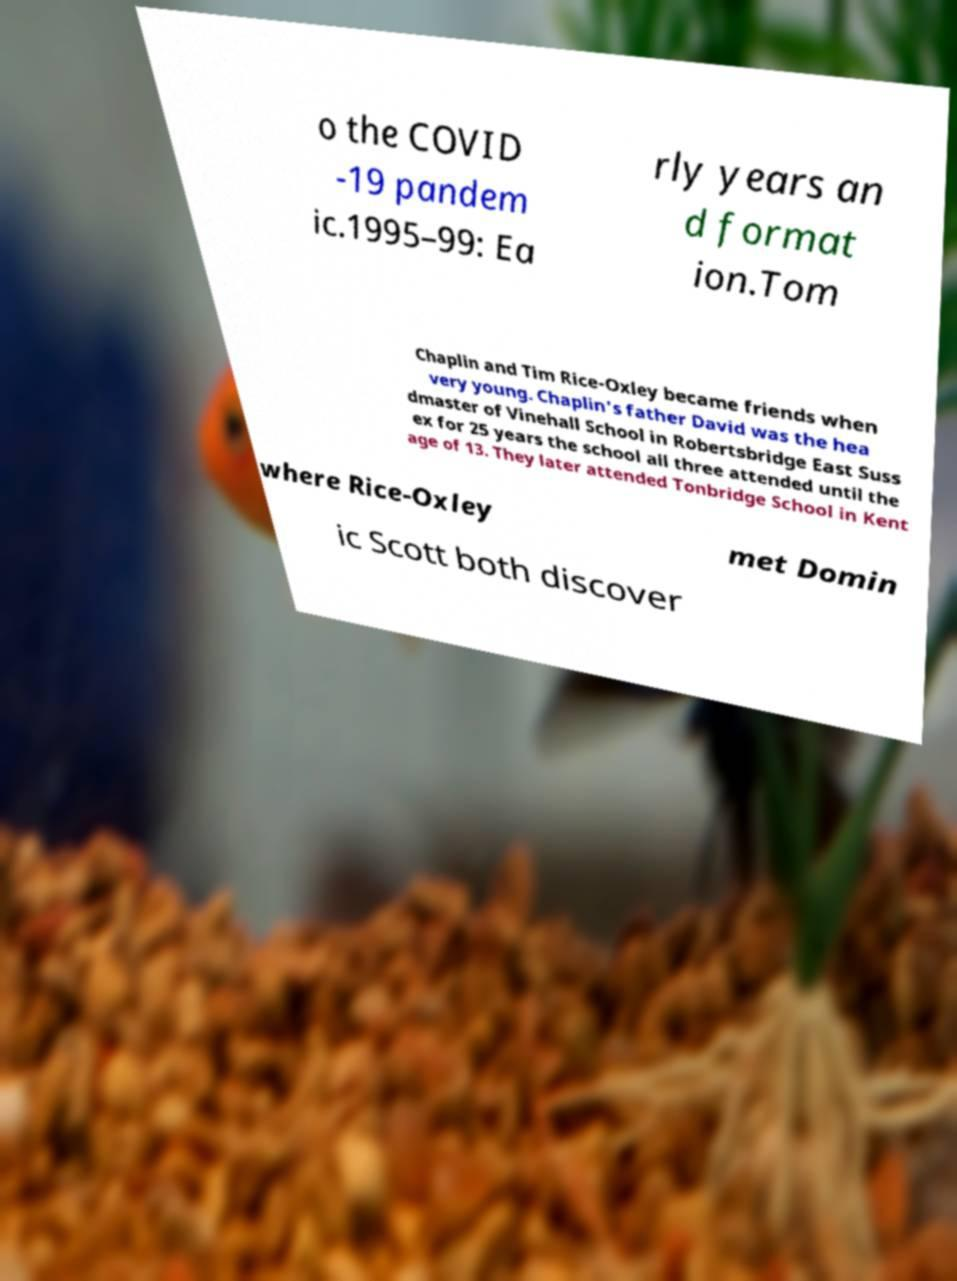Can you accurately transcribe the text from the provided image for me? o the COVID -19 pandem ic.1995–99: Ea rly years an d format ion.Tom Chaplin and Tim Rice-Oxley became friends when very young. Chaplin's father David was the hea dmaster of Vinehall School in Robertsbridge East Suss ex for 25 years the school all three attended until the age of 13. They later attended Tonbridge School in Kent where Rice-Oxley met Domin ic Scott both discover 